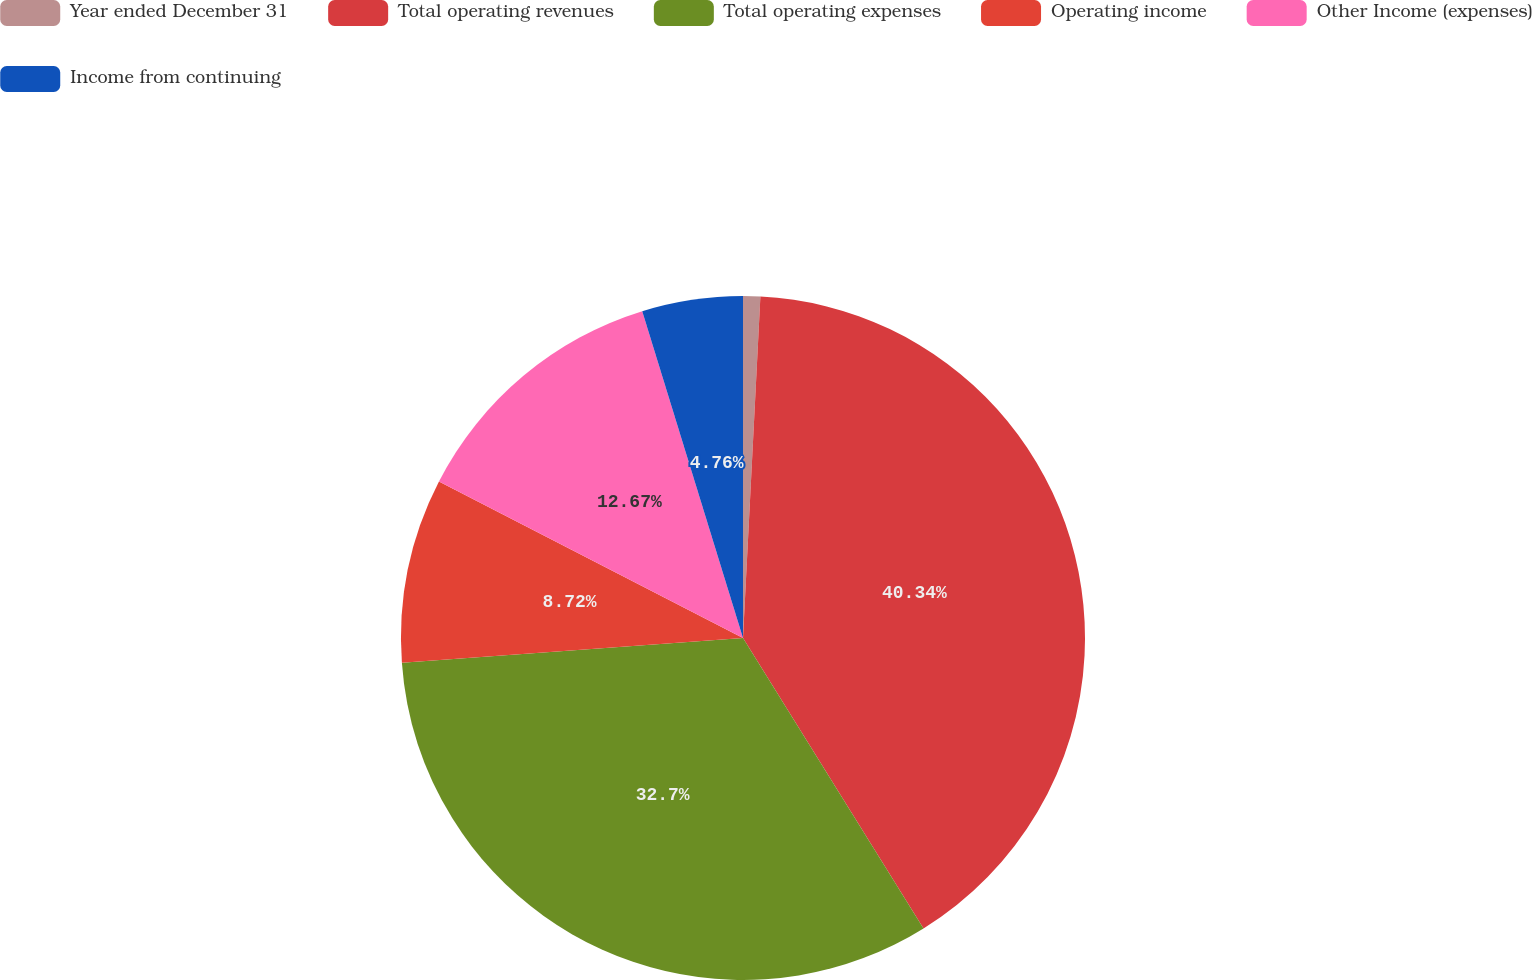Convert chart. <chart><loc_0><loc_0><loc_500><loc_500><pie_chart><fcel>Year ended December 31<fcel>Total operating revenues<fcel>Total operating expenses<fcel>Operating income<fcel>Other Income (expenses)<fcel>Income from continuing<nl><fcel>0.81%<fcel>40.34%<fcel>32.7%<fcel>8.72%<fcel>12.67%<fcel>4.76%<nl></chart> 